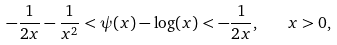<formula> <loc_0><loc_0><loc_500><loc_500>- \frac { 1 } { 2 x } - \frac { 1 } { x ^ { 2 } } < \psi ( x ) - \log ( x ) < - \frac { 1 } { 2 x } , \quad x > 0 ,</formula> 